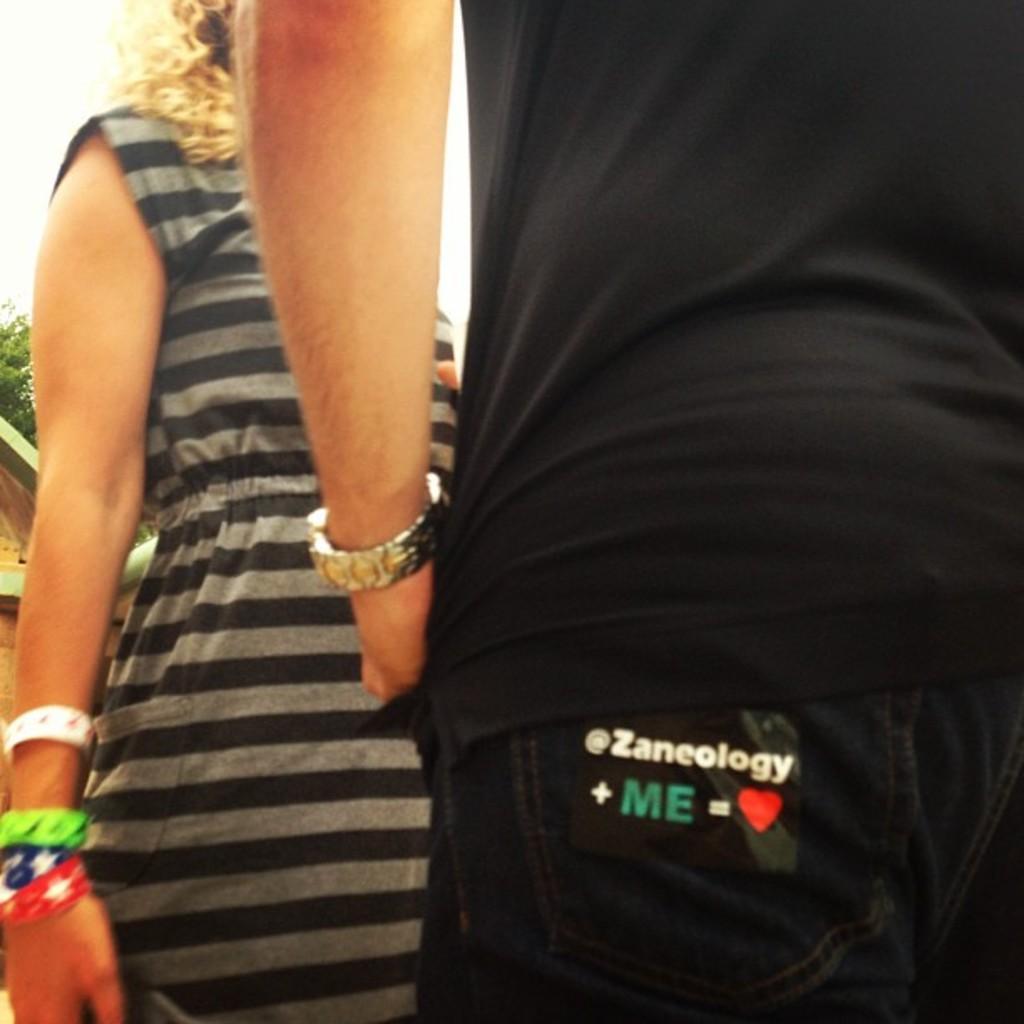Please provide a concise description of this image. In this image, we can see two people. Here we can see some text and symbols. On the left side of the image, we can see a house, tree and sky. 